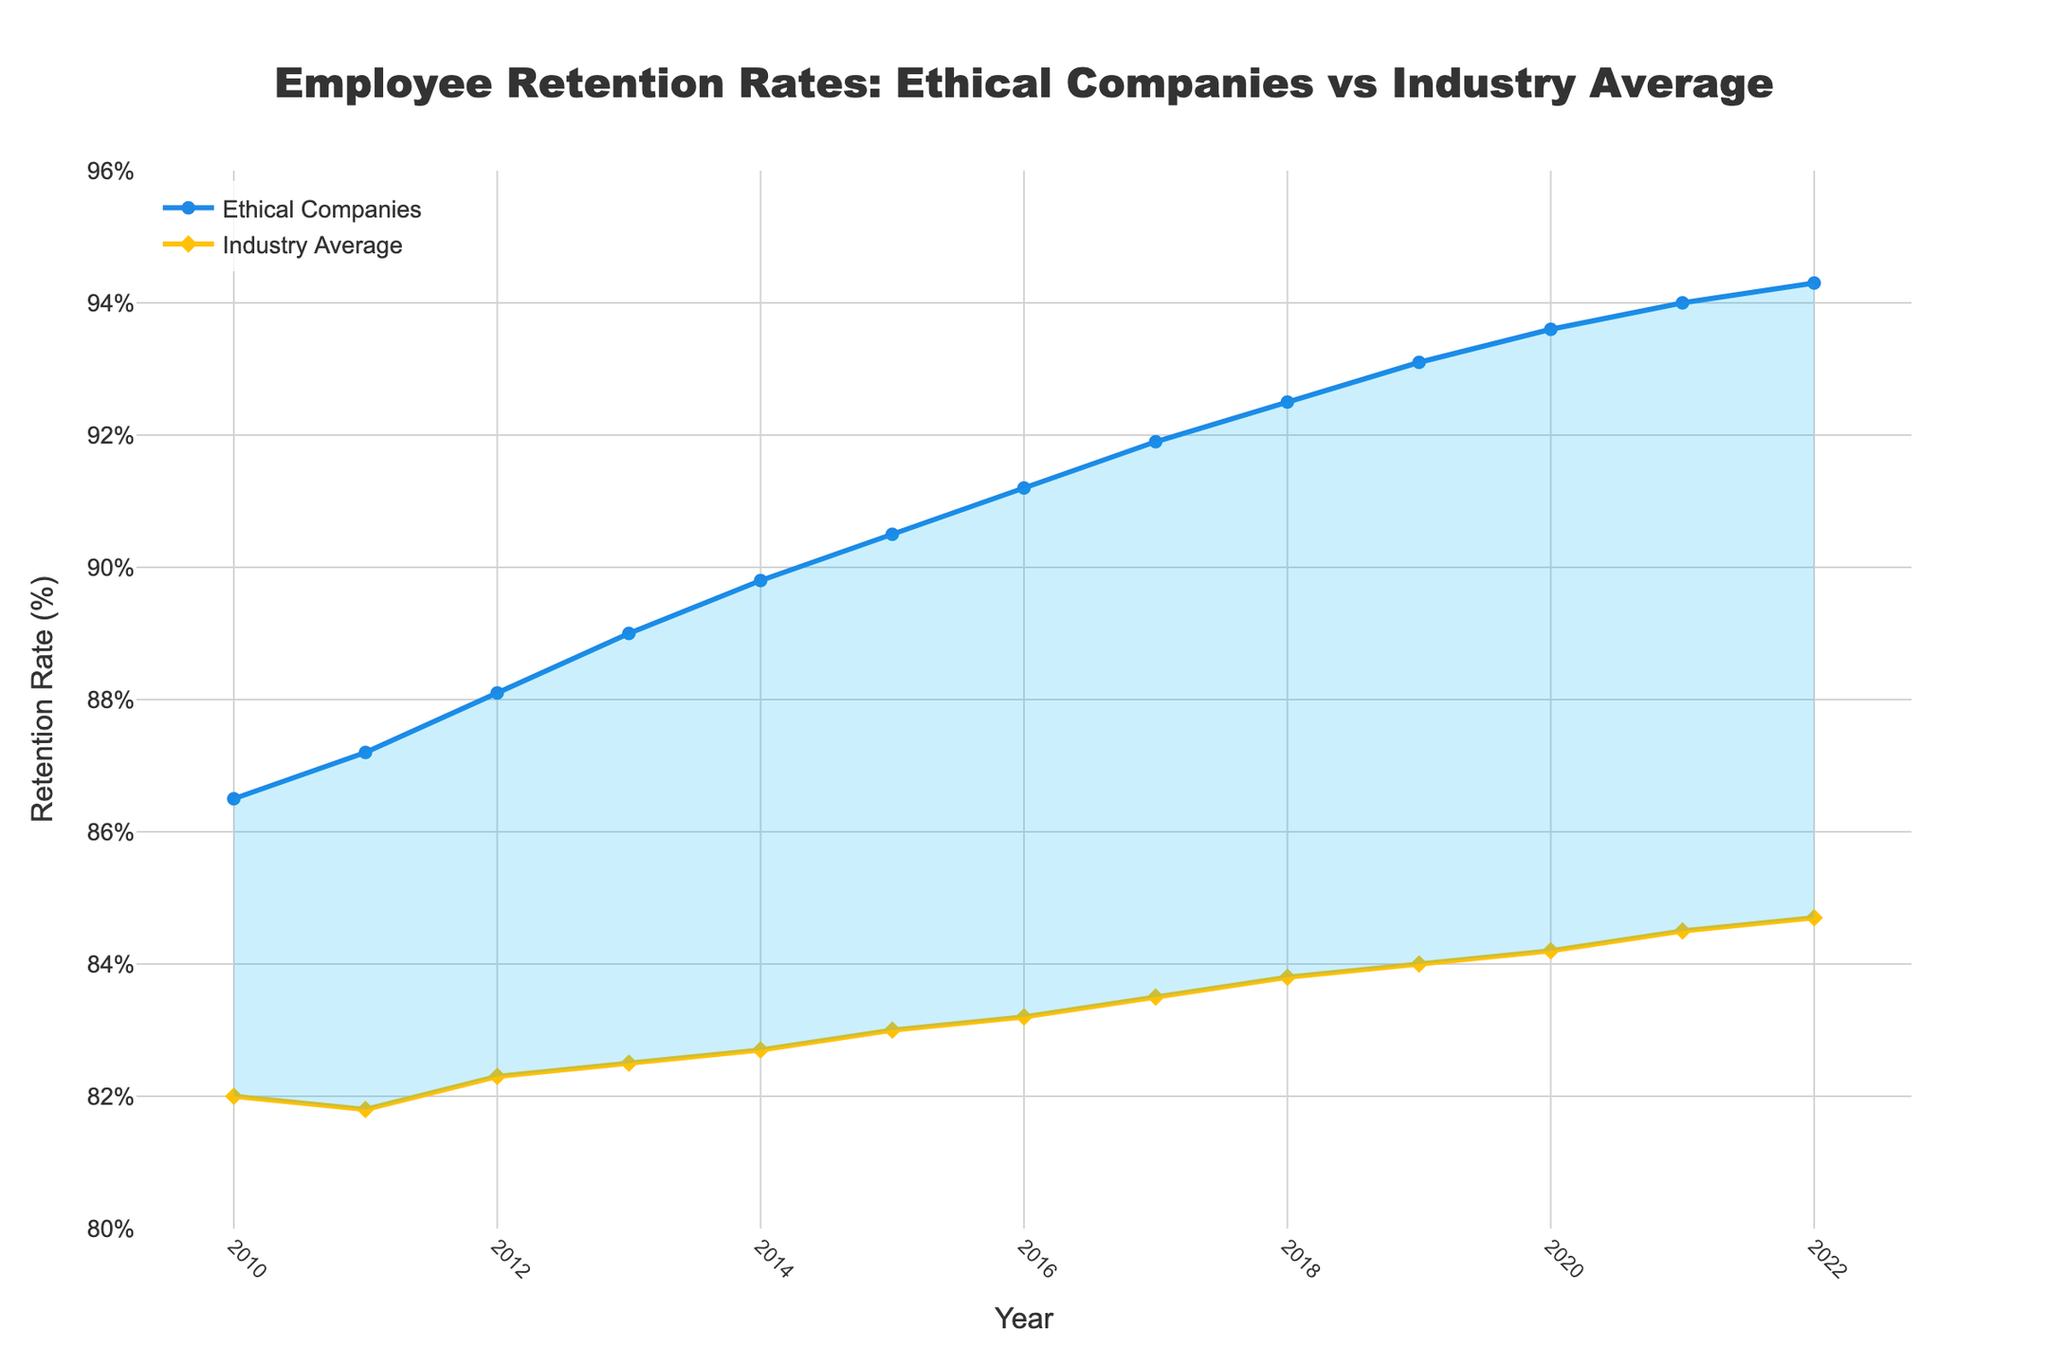How do the retention rates of ethical companies trend over time? Across the years 2010 to 2022, the retention rates of ethical companies show a consistent upward trend. By looking at the plotted line, it starts at 86.5% in 2010 and steadily rises to 94.3% in 2022.
Answer: Upward trend What is the difference in retention rates between ethical companies and the industry average in 2022? In 2022, the retention rate for ethical companies is 94.3%, while the industry average is 84.7%. The difference is 94.3% - 84.7%, which equals 9.6%.
Answer: 9.6% Which year had the smallest gap between ethical companies' retention rates and the industry average? The smallest gap appears in 2010. In that year, the retention rate for ethical companies was 86.5%, and for the industry average, it was 82.0%. The difference is 86.5% - 82.0% = 4.5%, which is the smallest difference over the years.
Answer: 2010 By how many percentage points did the retention rate for ethical companies increase from 2010 to 2015? In 2010, the retention rate was 86.5%, and in 2015, it was 90.5%. The increase is calculated as 90.5% - 86.5% = 4.0%.
Answer: 4.0% What visual attribute differentiates the data points for ethical companies and the industry average? The ethical companies' data points are represented by circles, whereas the industry average data points are represented by diamonds. This visual difference helps differentiate the two lines.
Answer: Marker shape Which year shows the largest retention rate increase for ethical companies compared to the previous year? The largest increase for ethical companies occurred between 2014 and 2015. The retention rate increased from 89.8% to 90.5%, which is an increase of 0.7 percentage points.
Answer: 2014 to 2015 Do ethical companies or the industry average have a higher retention rate in each year shown in the chart? In each year presented from 2010 to 2022, ethical companies consistently have a higher retention rate compared to the industry average. This is evident as the blue line representing ethical companies' retention rates is always above the yellow line representing the industry average.
Answer: Ethical companies What was the average retention rate for ethical companies over the period 2010 to 2022? To get the average retention rate for ethical companies from 2010 to 2022, sum up the retention rates for each year and divide by the number of years. The sum of the retention rates is (86.5 + 87.2 + 88.1 + 89.0 + 89.8 + 90.5 + 91.2 + 91.9 + 92.5 + 93.1 + 93.6 + 94.0 + 94.3) = 1190.7. Divide this sum by 13 years to get the average, which is 1190.7 / 13 = 91.6%.
Answer: 91.6% 